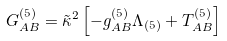<formula> <loc_0><loc_0><loc_500><loc_500>G _ { A B } ^ { ( 5 ) } = \tilde { \kappa } ^ { 2 } \left [ - g _ { A B } ^ { ( 5 ) } \Lambda _ { ( 5 ) } + T _ { A B } ^ { ( 5 ) } \right ]</formula> 